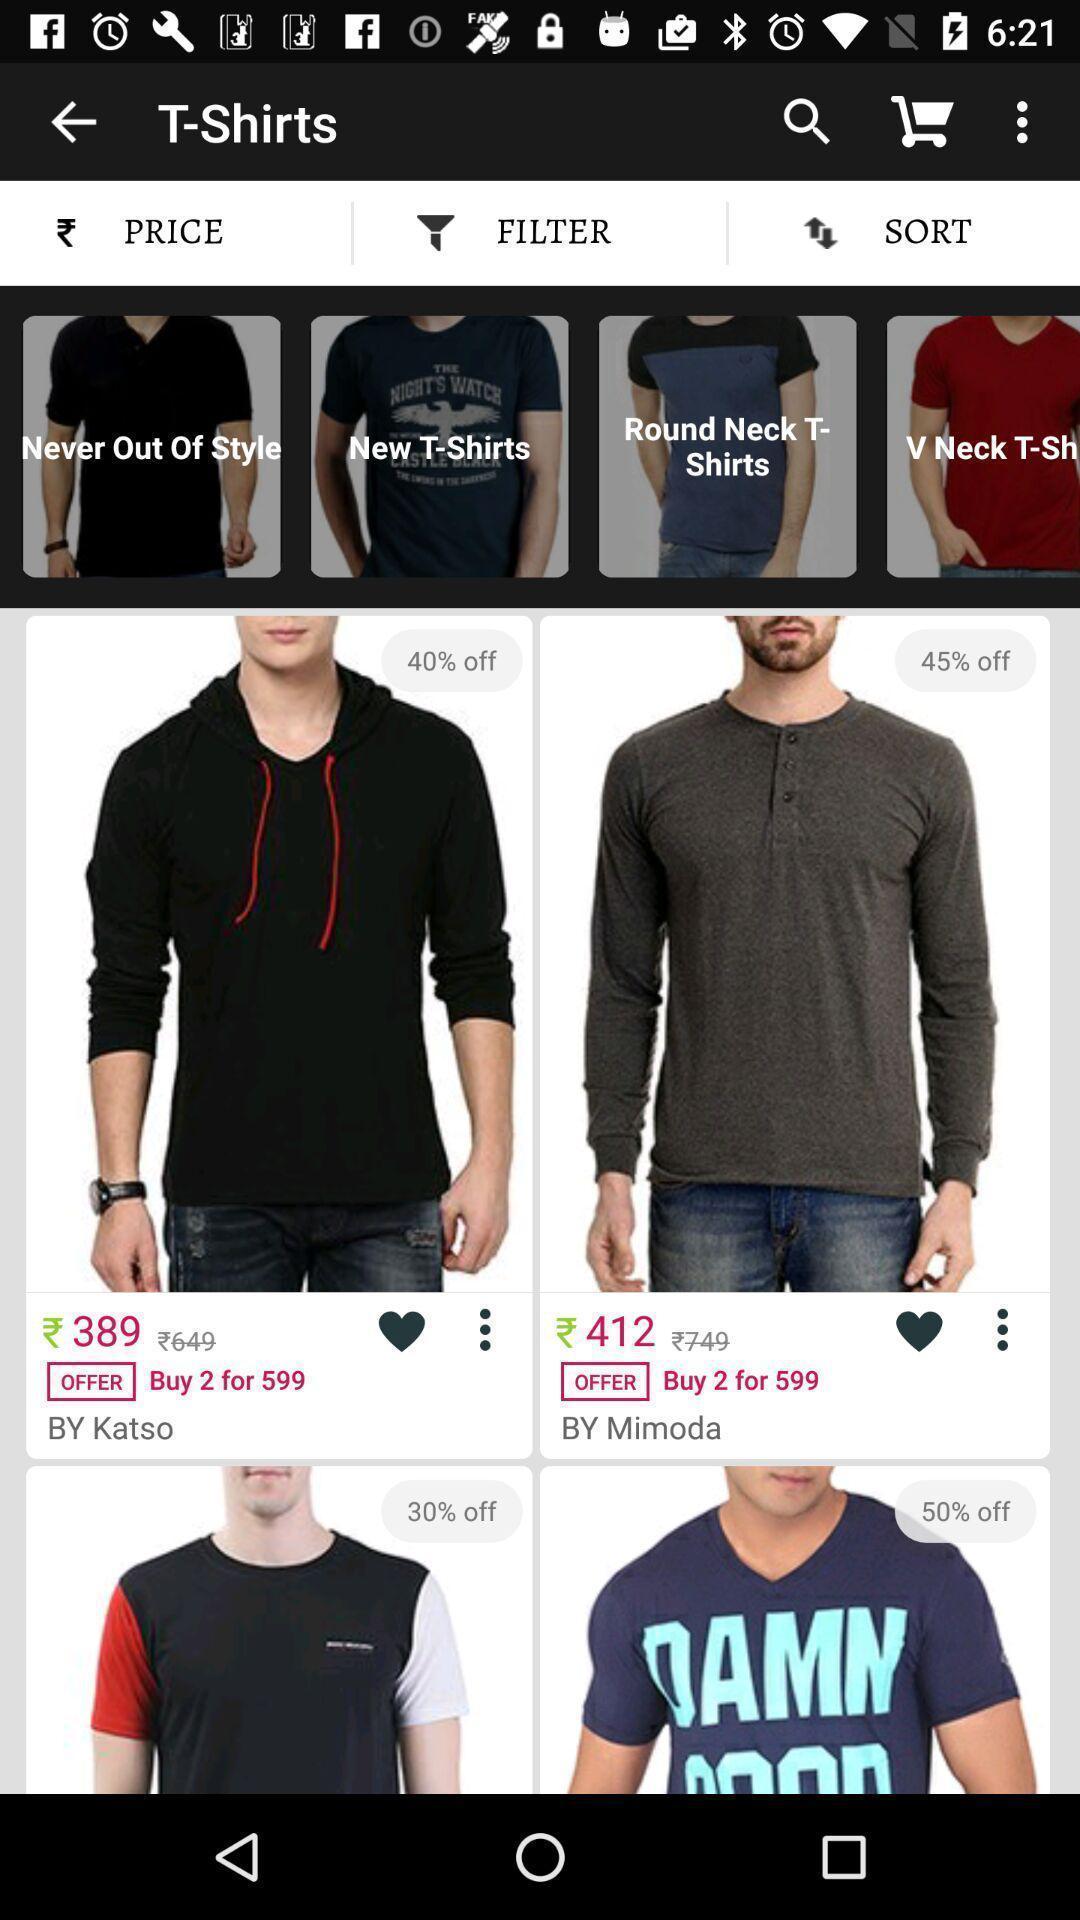Summarize the main components in this picture. Page showing different products on shopping app. 